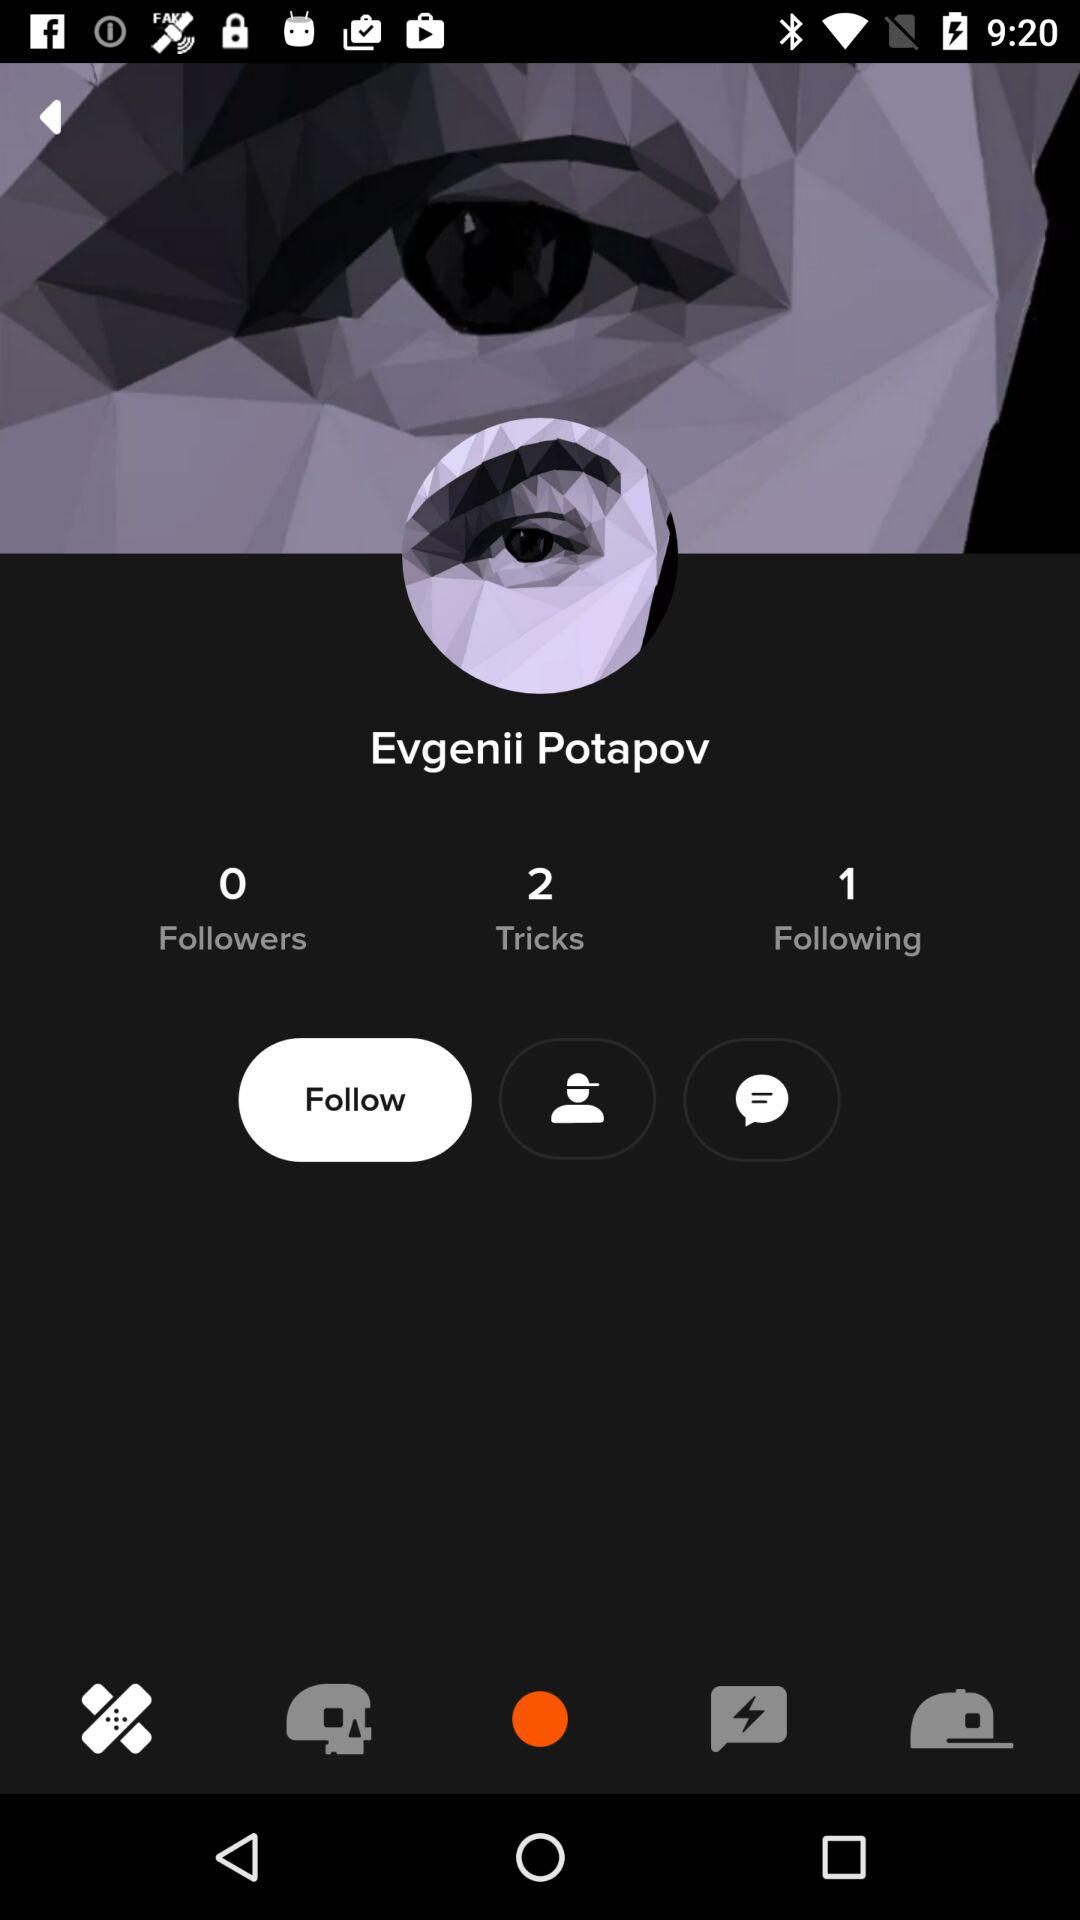What is the given number of tricks? The given number of tricks is 2. 